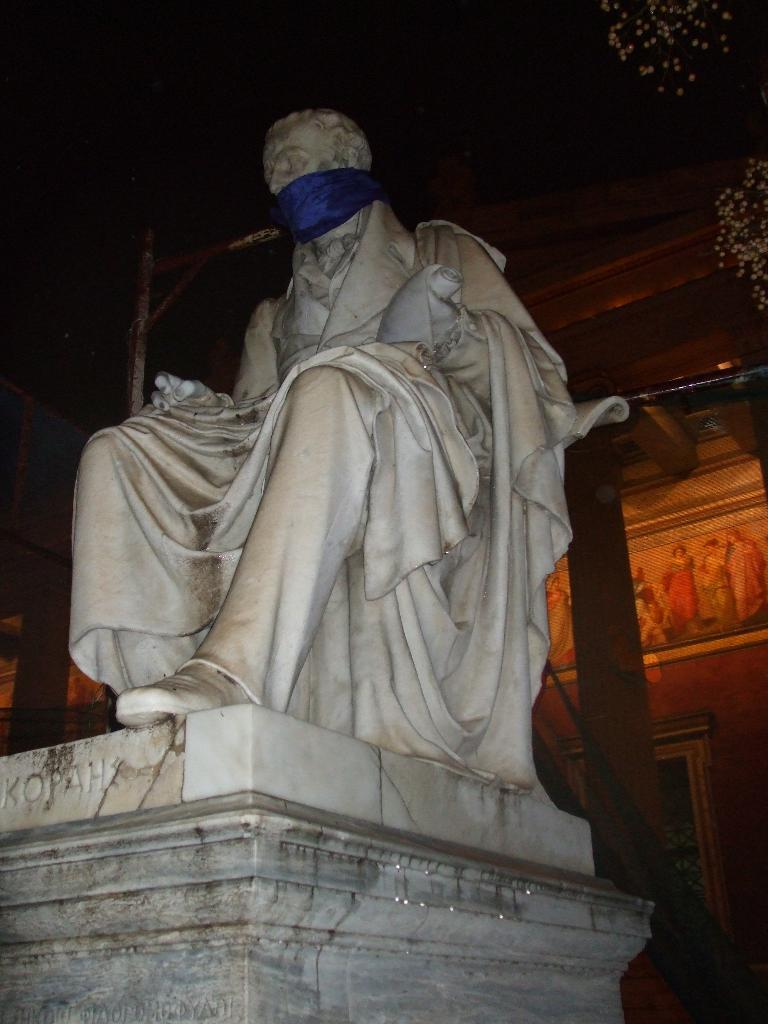What is the main subject of the picture? The main subject of the picture is a statue. Is there anything special about the statue? Yes, the statue has a blue ribbon tied to it. What can be seen in the background of the picture? There is a building in the background of the picture. How many toads are sitting on the statue in the image? There are no toads present in the image; it features a statue with a blue ribbon tied to it. What type of ice can be seen melting on the statue in the image? There is no ice present on the statue in the image. 